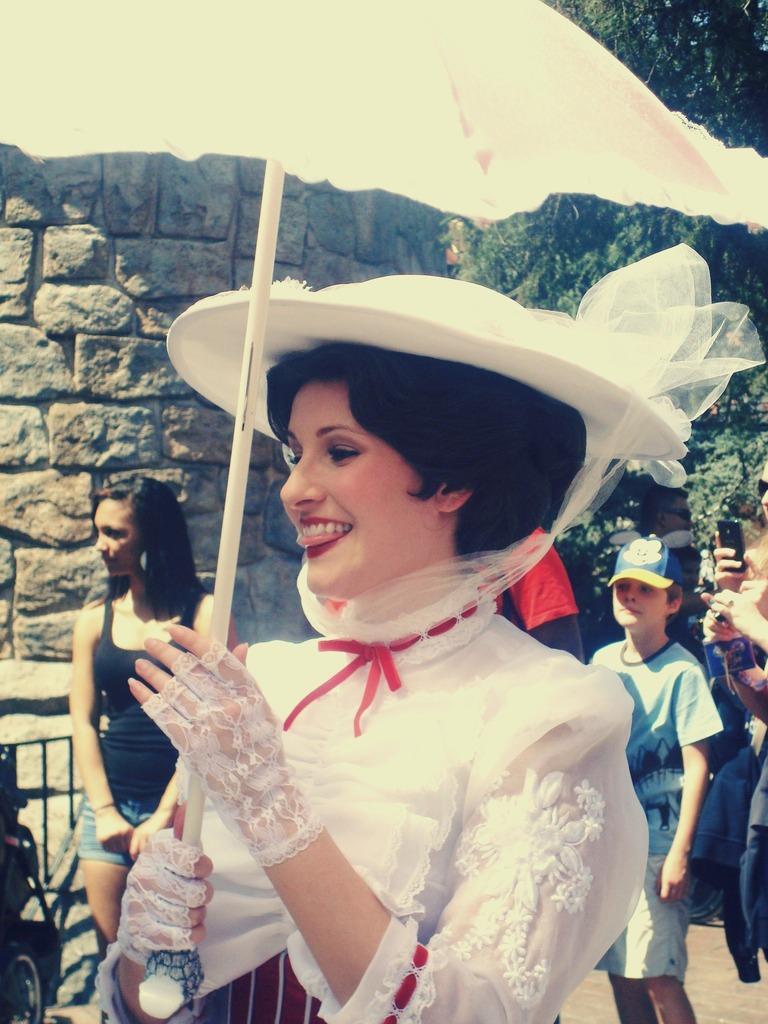Can you describe this image briefly? In the middle of the image a woman is standing and smiling and holding an umbrella. Behind her few people are standing. Behind them there is a wall and tree. 